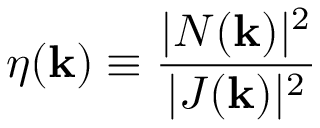Convert formula to latex. <formula><loc_0><loc_0><loc_500><loc_500>\eta ( k ) \equiv \frac { | N ( k ) | ^ { 2 } } { | J ( k ) | ^ { 2 } }</formula> 